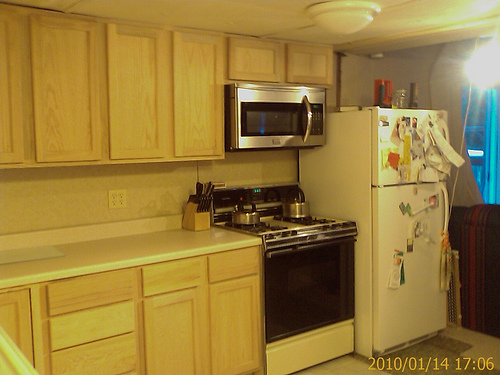Please identify all text content in this image. 2010 01 14 17 06 